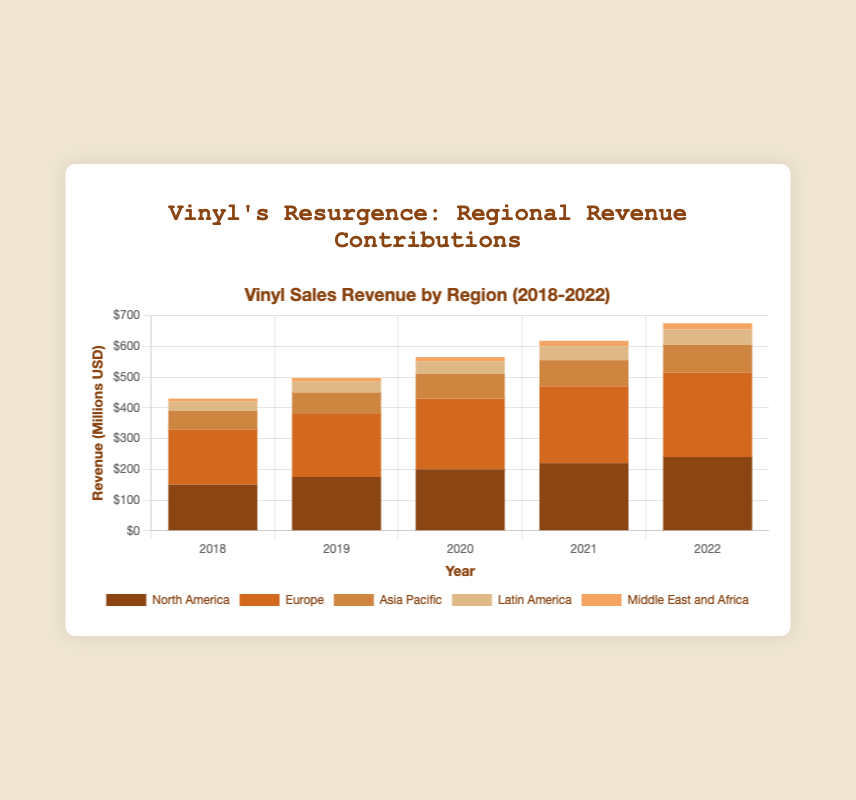What region contributed the most revenue to vinyl sales in 2022? Looking at the different colored sections of the stacked bars for 2022, the bar representing Europe is visually the tallest section, indicating it contributed the most revenue.
Answer: Europe Which year saw the highest total revenue from vinyl sales? To find the year with the highest total revenue, observe the overall heights of the stacked bars for each year. The bar for 2022 is tallest among all the years, indicating the highest total revenue.
Answer: 2022 By how much did revenue from North America in 2022 surpass that in 2018? Revenue from North America was $240 million in 2022 and $150 million in 2018. The difference is calculated as $240 million - $150 million = $90 million.
Answer: $90 million Which year saw the lowest revenue from the Middle East and Africa? By comparing the heights of the bars specifically for the Middle East and Africa (colored section) across all years, the smallest section appears in 2018.
Answer: 2018 How much revenue did Asia Pacific generate in total from 2018 to 2022? Sum the revenue contributions of Asia Pacific for each year: $60 million (2018) + $70 million (2019) + $80 million (2020) + $85 million (2021) + $90 million (2022) = $385 million.
Answer: $385 million What is the trend of Europe’s revenue contribution from 2018 to 2022? Observing the height of Europe’s section in the stacked bars from 2018 to 2022, the sections have a generally upward trend each year from $180 million (2018) to $275 million (2022).
Answer: Upward trend Which region showed the most consistent increase in revenue from 2018 to 2022? By examining the stacked bars, North America consistently increases each year from $150 million in 2018 to $240 million in 2022, without any dips.
Answer: North America How much total revenue did vinyl sales generate across all regions in 2020? Add up the revenue contributions from all regions in 2020: $200 million (North America) + $230 million (Europe) + $80 million (Asia Pacific) + $40 million (Latin America) + $15 million (Middle East and Africa) = $565 million.
Answer: $565 million What was the combined revenue from Latin America and the Middle East and Africa in 2021? Summing the revenue from Latin America and the Middle East and Africa for 2021: $45 million (Latin America) + $18 million (Middle East and Africa) = $63 million.
Answer: $63 million 